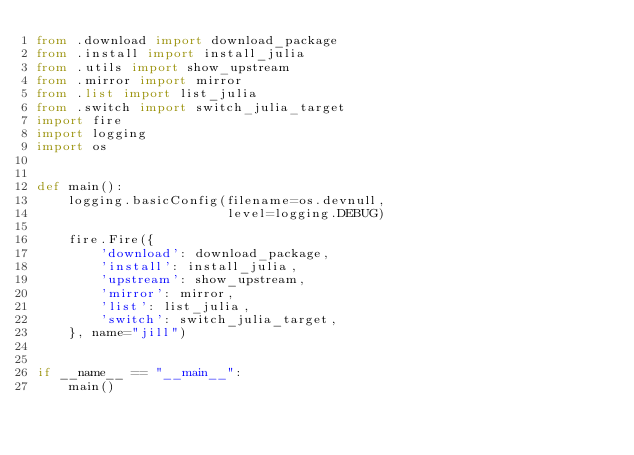<code> <loc_0><loc_0><loc_500><loc_500><_Python_>from .download import download_package
from .install import install_julia
from .utils import show_upstream
from .mirror import mirror
from .list import list_julia
from .switch import switch_julia_target
import fire
import logging
import os


def main():
    logging.basicConfig(filename=os.devnull,
                        level=logging.DEBUG)

    fire.Fire({
        'download': download_package,
        'install': install_julia,
        'upstream': show_upstream,
        'mirror': mirror,
        'list': list_julia,
        'switch': switch_julia_target,
    }, name="jill")


if __name__ == "__main__":
    main()
</code> 